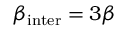Convert formula to latex. <formula><loc_0><loc_0><loc_500><loc_500>\beta _ { i n t e r } = 3 \beta</formula> 